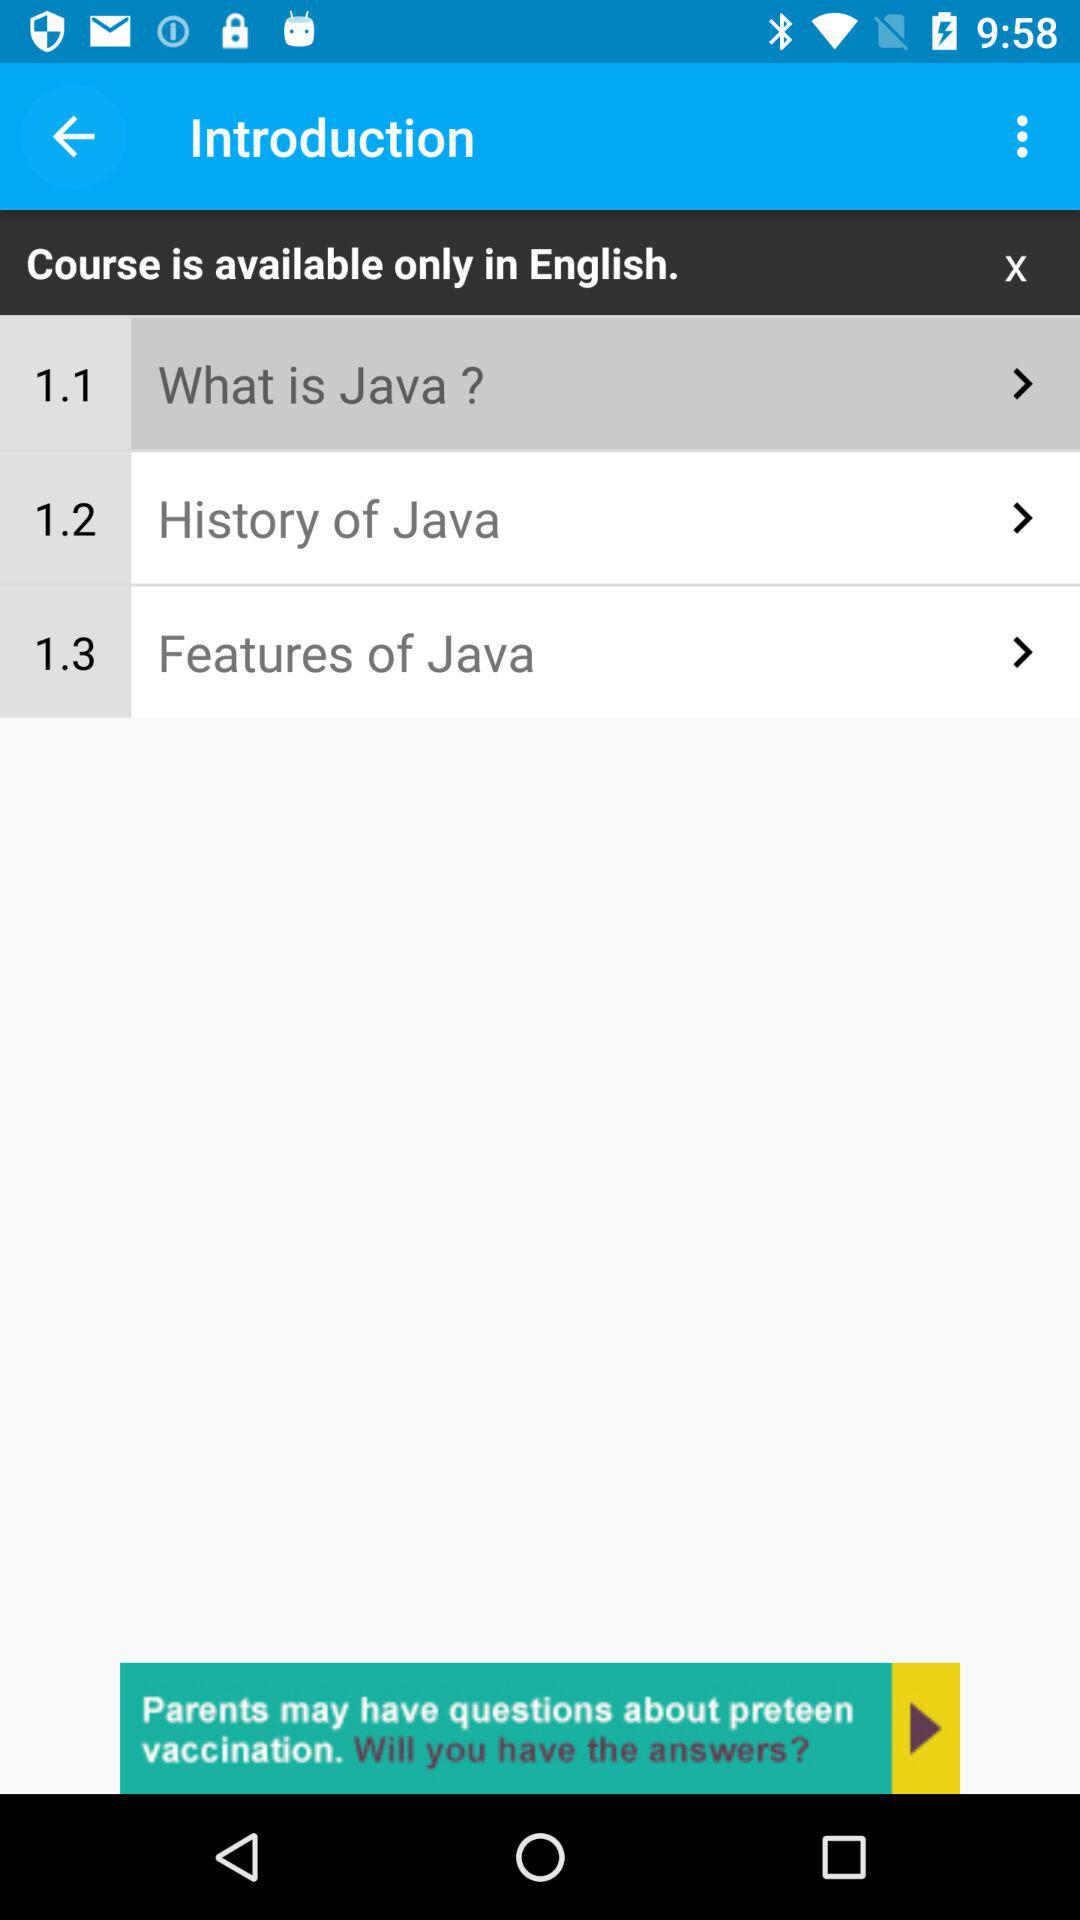In which language is the course available? The course is available only in English language. 